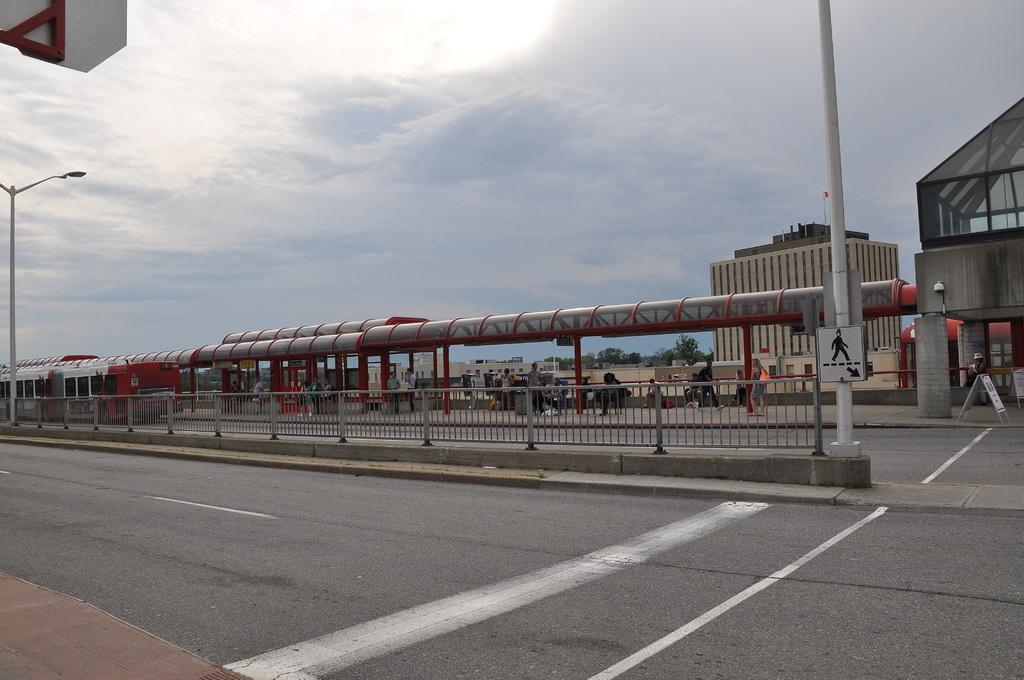Can you describe this image briefly? This picture shows two way road and we see few people walking on the sidewalk and few are seated on the bench and we see few buildings and trees and pole lights and a cloudy sky. 